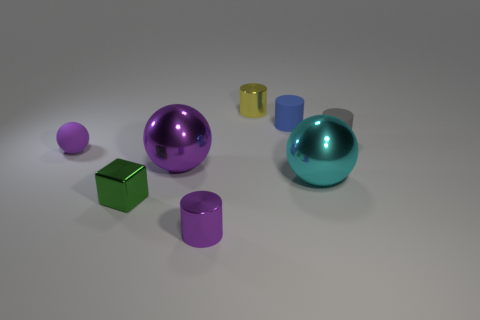Subtract all rubber balls. How many balls are left? 2 Subtract all spheres. How many objects are left? 5 Subtract 2 cylinders. How many cylinders are left? 2 Subtract all blue rubber cylinders. Subtract all large cyan balls. How many objects are left? 6 Add 8 big purple spheres. How many big purple spheres are left? 9 Add 8 tiny gray things. How many tiny gray things exist? 9 Add 2 objects. How many objects exist? 10 Subtract all purple cylinders. How many cylinders are left? 3 Subtract 0 blue balls. How many objects are left? 8 Subtract all purple balls. Subtract all gray cylinders. How many balls are left? 1 